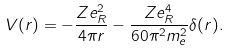<formula> <loc_0><loc_0><loc_500><loc_500>V ( r ) = - \frac { Z e _ { R } ^ { 2 } } { 4 \pi r } - \frac { Z e _ { R } ^ { 4 } } { 6 0 \pi ^ { 2 } m _ { e } ^ { 2 } } \delta ( r ) .</formula> 